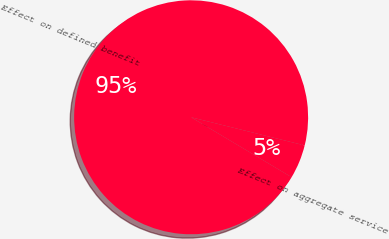Convert chart to OTSL. <chart><loc_0><loc_0><loc_500><loc_500><pie_chart><fcel>Effect on aggregate service<fcel>Effect on defined benefit<nl><fcel>4.69%<fcel>95.31%<nl></chart> 